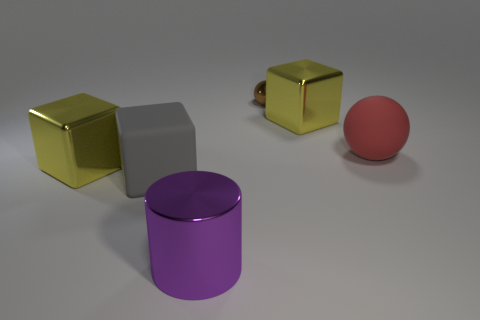Is the red matte thing the same size as the purple object?
Give a very brief answer. Yes. What is the size of the object that is both behind the large red matte sphere and right of the tiny metal sphere?
Your response must be concise. Large. Is the number of big shiny cubes that are left of the tiny metal ball greater than the number of big yellow things that are left of the large rubber block?
Provide a succinct answer. No. There is another small thing that is the same shape as the red rubber thing; what is its color?
Offer a very short reply. Brown. Do the shiny thing on the right side of the metallic ball and the big matte sphere have the same color?
Keep it short and to the point. No. How many cyan metal balls are there?
Your response must be concise. 0. Is the material of the big yellow cube to the right of the small metal thing the same as the large gray thing?
Offer a very short reply. No. Is there anything else that has the same material as the brown thing?
Offer a terse response. Yes. What number of purple cylinders are in front of the big yellow thing in front of the yellow metallic cube on the right side of the big purple shiny thing?
Ensure brevity in your answer.  1. What size is the shiny cylinder?
Your answer should be compact. Large. 